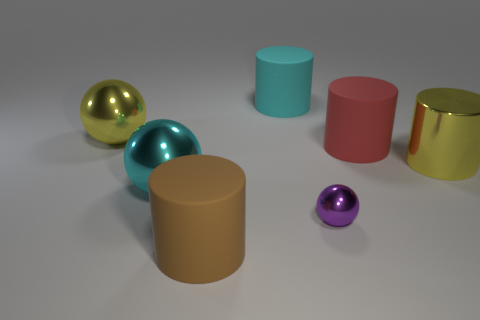Subtract all matte cylinders. How many cylinders are left? 1 Add 1 big cyan matte objects. How many objects exist? 8 Subtract all purple spheres. How many spheres are left? 2 Subtract 2 balls. How many balls are left? 1 Subtract all green spheres. Subtract all red cylinders. How many spheres are left? 3 Add 4 big shiny spheres. How many big shiny spheres exist? 6 Subtract 1 red cylinders. How many objects are left? 6 Subtract all spheres. How many objects are left? 4 Subtract all green metallic blocks. Subtract all yellow balls. How many objects are left? 6 Add 1 tiny purple metallic things. How many tiny purple metallic things are left? 2 